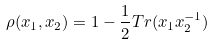Convert formula to latex. <formula><loc_0><loc_0><loc_500><loc_500>\rho ( x _ { 1 } , x _ { 2 } ) = 1 - \frac { 1 } { 2 } T r ( x _ { 1 } x _ { 2 } ^ { - 1 } )</formula> 